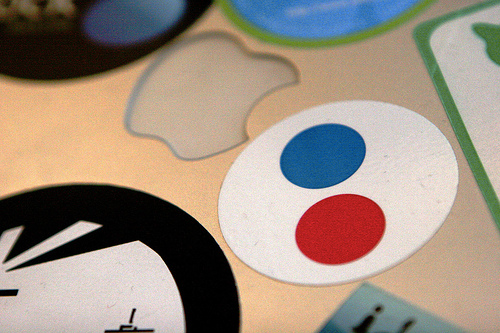<image>
Is there a red circle under the blue circle? Yes. The red circle is positioned underneath the blue circle, with the blue circle above it in the vertical space. Is there a blue circle on the white circle? Yes. Looking at the image, I can see the blue circle is positioned on top of the white circle, with the white circle providing support. 